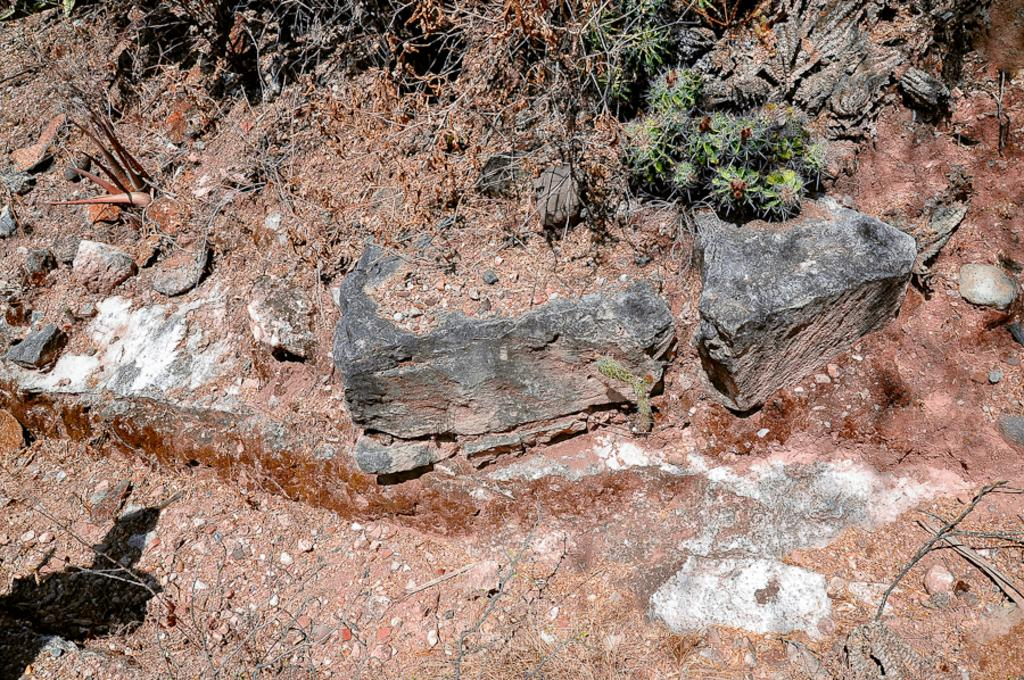What type of natural elements can be seen on the ground in the image? There are stones, grass, and sticks on the ground in the image. What time of day is it on the stage in the image? There is no stage present in the image, and therefore no specific time of day can be determined. How many hours does it take for the grass to grow in the image? The image does not provide information about the growth rate of the grass, so it is not possible to determine how many hours it takes for the grass to grow. 